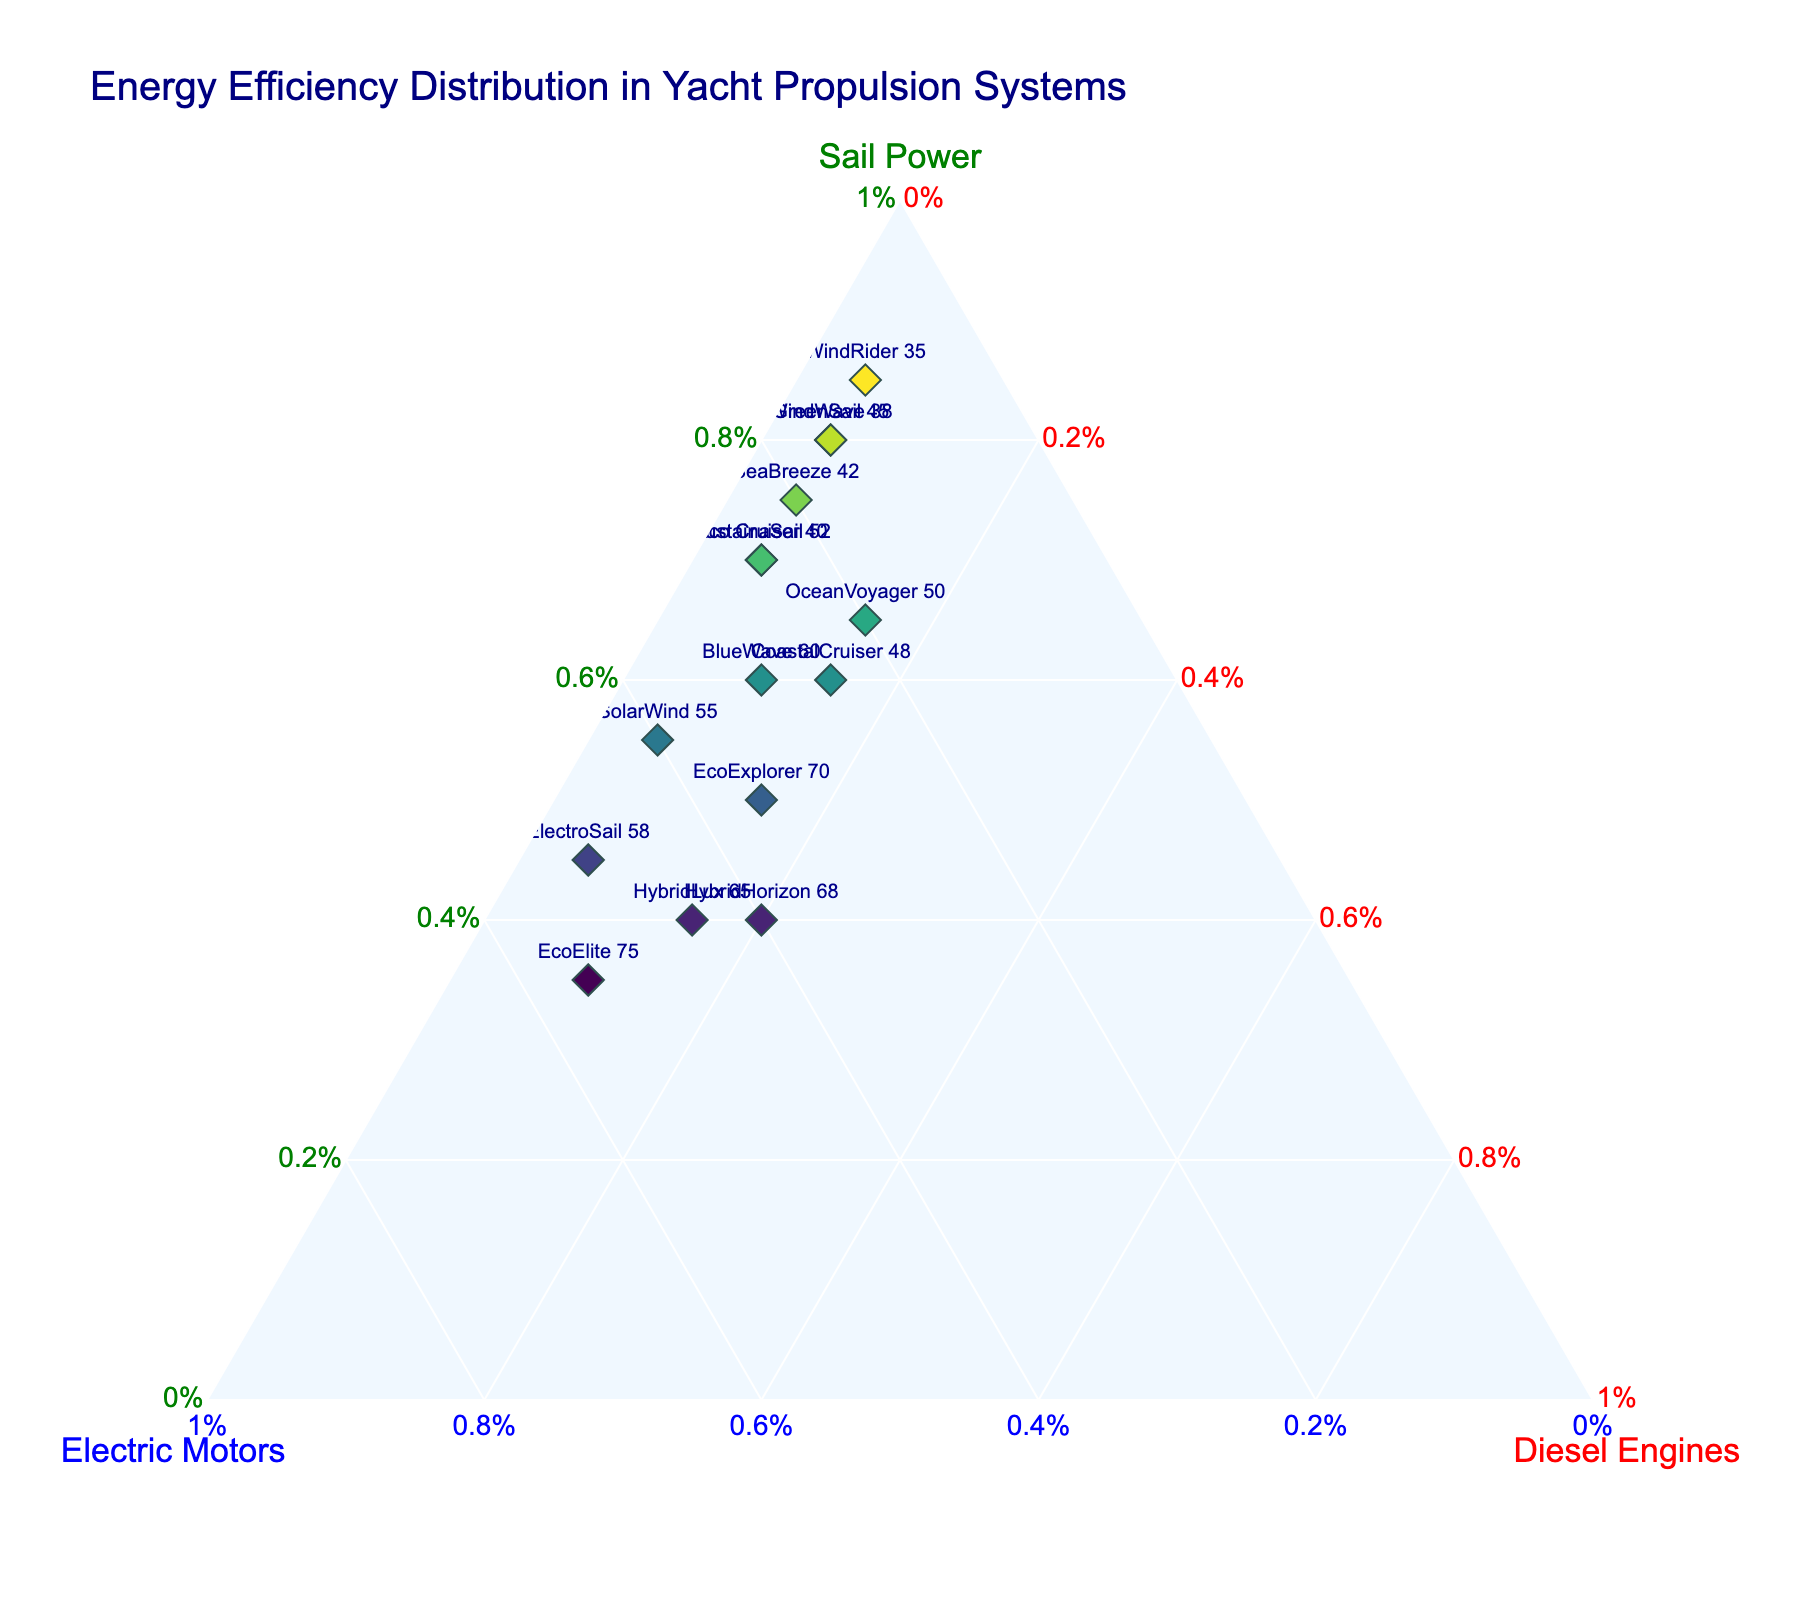what is the title of the plot? Refer to the top of the plot where the heading is displayed. It states the topic of the visual representation.
Answer: Energy Efficiency Distribution in Yacht Propulsion Systems How many yachts rely primarily on sail power (over 70%)? Identify the data points on the ternary plot where the 'Sail Power' value exceeds 70%. Count these data points to get the answer.
Answer: 5 Which yacht has the highest proportion of electric motors in its propulsion system? Look for the data point with the highest 'Electric Motors' value on the plot. Cross-reference it with the yacht names.
Answer: EcoElite 75 What is the average proportion of diesel engines among the yachts? Sum up all the 'Diesel Engines' proportions and divide by the number of yachts. Sum: 0.05 + 0.05 + 0.10 + 0.05 + 0.15 + 0.15 + 0.15 + 0.05 + 0.05 + 0.05 + 0.10 + 0.15 + 0.05 + 0.05 + 0.20 = 1.35, divide by 15 yachts: 1.35 / 15 = 0.09
Answer: 0.09 Which yacht has the most balanced propulsion system in terms of energy sources? A balanced propulsion system would have nearly equal proportions for sail power, electric motors, and diesel engines. Locate the data point closest to equal values in all three axes.
Answer: HybridHorizon 68 Between 'BlueWave 60' and 'HybridLux 65,' which yacht has a higher reliance on electric motors? Compare the 'Electric Motors' proportions of 'BlueWave 60' and 'HybridLux 65'. 'BlueWave 60' has 0.30 while 'HybridLux 65' has 0.45.
Answer: HybridLux 65 Which axis on the plot represents the proportion of diesel engines? Identify the axis labeled with 'Diesel Engines' percentage on the ternary plot.
Answer: The right axis For 'EcoExplorer 70', what is the combined proportion of sail power and electric motors? Add the proportions of 'Sail Power' (0.50) and 'Electric Motors' (0.35) for the 'EcoExplorer 70'. 0.50 + 0.35 = 0.85
Answer: 0.85 Which yacht has the smallest reliance on sail power? Find the data point with the lowest 'Sail Power' value and cross-reference with the yacht names.
Answer: EcoElite 75 